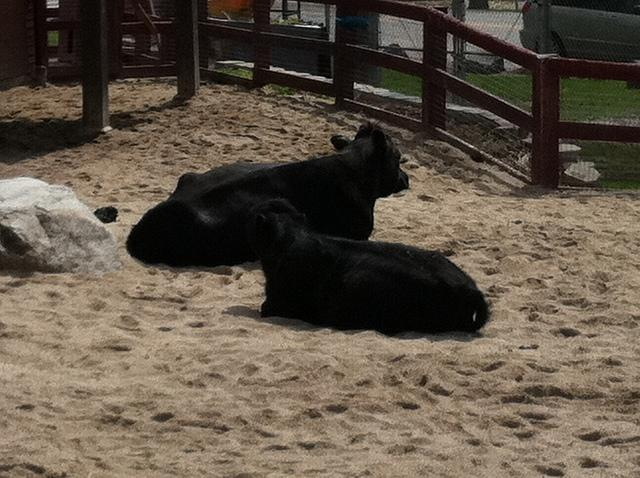What are the cows inside of? Please explain your reasoning. fence. They have been enclosed by wood and wire mesh fence. 